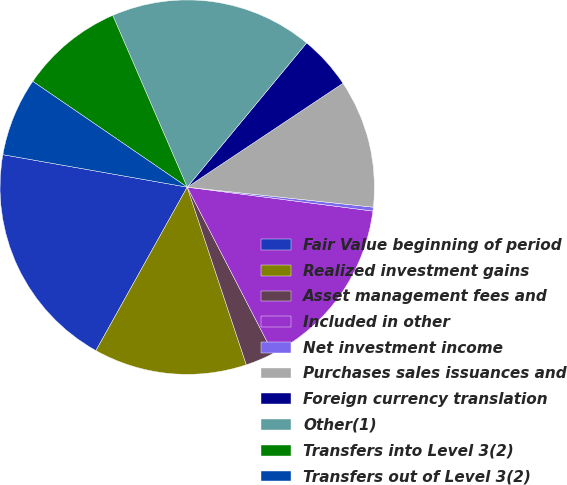Convert chart to OTSL. <chart><loc_0><loc_0><loc_500><loc_500><pie_chart><fcel>Fair Value beginning of period<fcel>Realized investment gains<fcel>Asset management fees and<fcel>Included in other<fcel>Net investment income<fcel>Purchases sales issuances and<fcel>Foreign currency translation<fcel>Other(1)<fcel>Transfers into Level 3(2)<fcel>Transfers out of Level 3(2)<nl><fcel>19.67%<fcel>13.22%<fcel>2.48%<fcel>15.37%<fcel>0.33%<fcel>11.07%<fcel>4.63%<fcel>17.52%<fcel>8.93%<fcel>6.78%<nl></chart> 